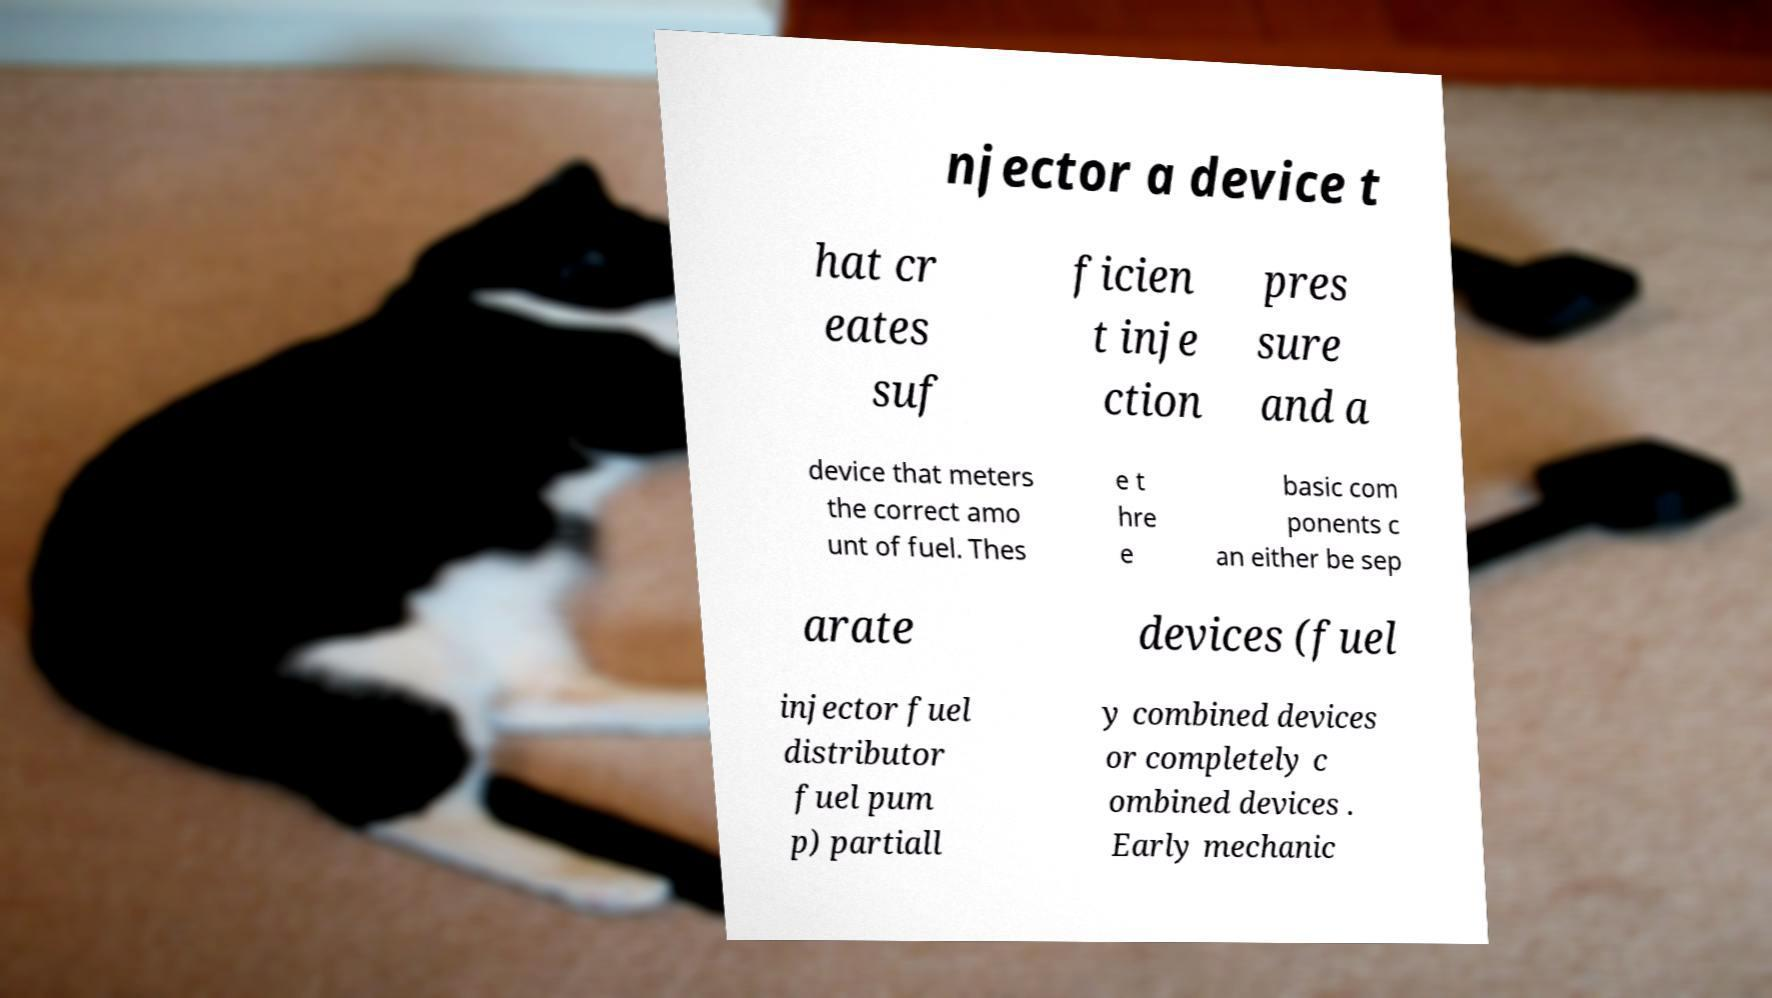There's text embedded in this image that I need extracted. Can you transcribe it verbatim? njector a device t hat cr eates suf ficien t inje ction pres sure and a device that meters the correct amo unt of fuel. Thes e t hre e basic com ponents c an either be sep arate devices (fuel injector fuel distributor fuel pum p) partiall y combined devices or completely c ombined devices . Early mechanic 